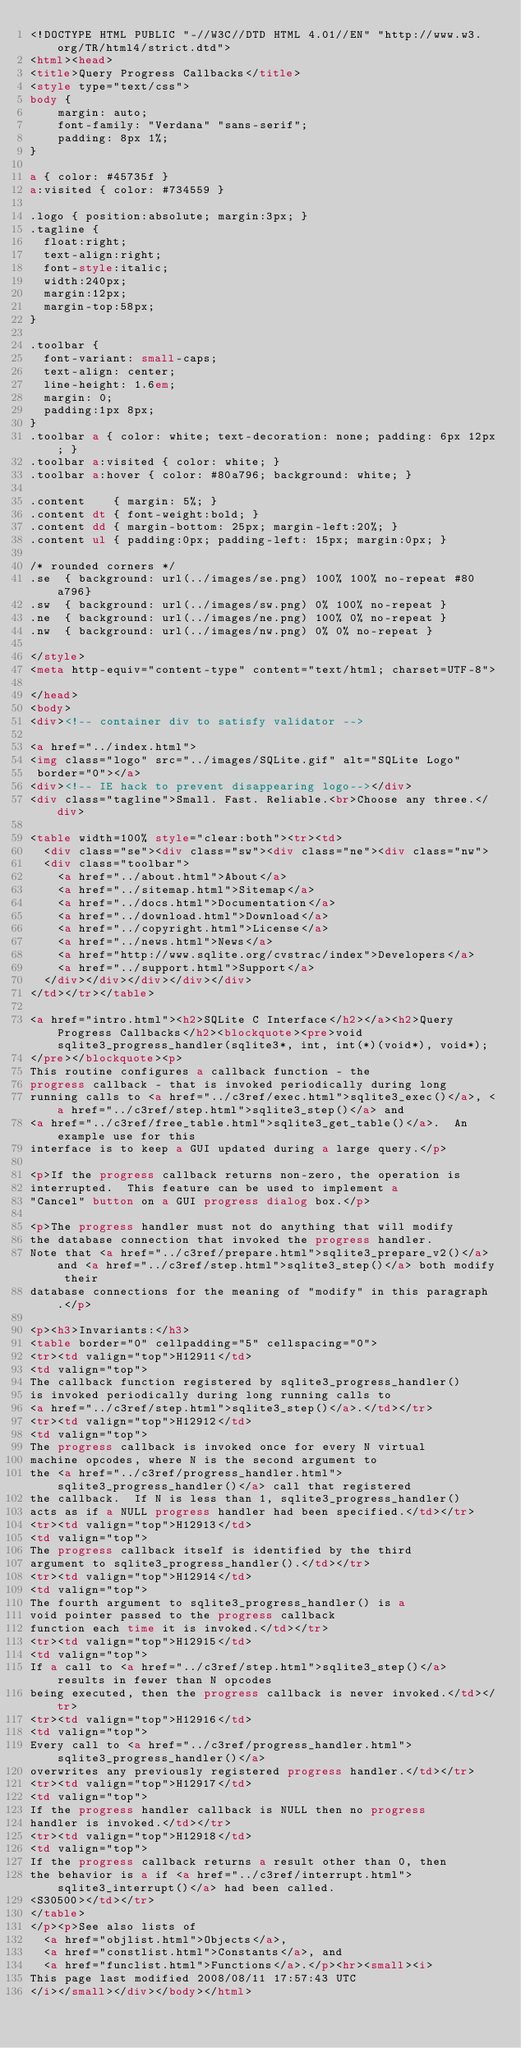<code> <loc_0><loc_0><loc_500><loc_500><_HTML_><!DOCTYPE HTML PUBLIC "-//W3C//DTD HTML 4.01//EN" "http://www.w3.org/TR/html4/strict.dtd">
<html><head>
<title>Query Progress Callbacks</title>
<style type="text/css">
body {
    margin: auto;
    font-family: "Verdana" "sans-serif";
    padding: 8px 1%;
}

a { color: #45735f }
a:visited { color: #734559 }

.logo { position:absolute; margin:3px; }
.tagline {
  float:right;
  text-align:right;
  font-style:italic;
  width:240px;
  margin:12px;
  margin-top:58px;
}

.toolbar {
  font-variant: small-caps;
  text-align: center;
  line-height: 1.6em;
  margin: 0;
  padding:1px 8px;
}
.toolbar a { color: white; text-decoration: none; padding: 6px 12px; }
.toolbar a:visited { color: white; }
.toolbar a:hover { color: #80a796; background: white; }

.content    { margin: 5%; }
.content dt { font-weight:bold; }
.content dd { margin-bottom: 25px; margin-left:20%; }
.content ul { padding:0px; padding-left: 15px; margin:0px; }

/* rounded corners */
.se  { background: url(../images/se.png) 100% 100% no-repeat #80a796}
.sw  { background: url(../images/sw.png) 0% 100% no-repeat }
.ne  { background: url(../images/ne.png) 100% 0% no-repeat }
.nw  { background: url(../images/nw.png) 0% 0% no-repeat }

</style>
<meta http-equiv="content-type" content="text/html; charset=UTF-8">
  
</head>
<body>
<div><!-- container div to satisfy validator -->

<a href="../index.html">
<img class="logo" src="../images/SQLite.gif" alt="SQLite Logo"
 border="0"></a>
<div><!-- IE hack to prevent disappearing logo--></div>
<div class="tagline">Small. Fast. Reliable.<br>Choose any three.</div>

<table width=100% style="clear:both"><tr><td>
  <div class="se"><div class="sw"><div class="ne"><div class="nw">
  <div class="toolbar">
    <a href="../about.html">About</a>
    <a href="../sitemap.html">Sitemap</a>
    <a href="../docs.html">Documentation</a>
    <a href="../download.html">Download</a>
    <a href="../copyright.html">License</a>
    <a href="../news.html">News</a>
    <a href="http://www.sqlite.org/cvstrac/index">Developers</a>
    <a href="../support.html">Support</a>
  </div></div></div></div></div>
</td></tr></table>
  
<a href="intro.html"><h2>SQLite C Interface</h2></a><h2>Query Progress Callbacks</h2><blockquote><pre>void sqlite3_progress_handler(sqlite3*, int, int(*)(void*), void*);
</pre></blockquote><p>
This routine configures a callback function - the
progress callback - that is invoked periodically during long
running calls to <a href="../c3ref/exec.html">sqlite3_exec()</a>, <a href="../c3ref/step.html">sqlite3_step()</a> and
<a href="../c3ref/free_table.html">sqlite3_get_table()</a>.  An example use for this
interface is to keep a GUI updated during a large query.</p>

<p>If the progress callback returns non-zero, the operation is
interrupted.  This feature can be used to implement a
"Cancel" button on a GUI progress dialog box.</p>

<p>The progress handler must not do anything that will modify
the database connection that invoked the progress handler.
Note that <a href="../c3ref/prepare.html">sqlite3_prepare_v2()</a> and <a href="../c3ref/step.html">sqlite3_step()</a> both modify their
database connections for the meaning of "modify" in this paragraph.</p>

<p><h3>Invariants:</h3>
<table border="0" cellpadding="5" cellspacing="0">
<tr><td valign="top">H12911</td> 
<td valign="top">
The callback function registered by sqlite3_progress_handler()
is invoked periodically during long running calls to
<a href="../c3ref/step.html">sqlite3_step()</a>.</td></tr>
<tr><td valign="top">H12912</td> 
<td valign="top">
The progress callback is invoked once for every N virtual
machine opcodes, where N is the second argument to
the <a href="../c3ref/progress_handler.html">sqlite3_progress_handler()</a> call that registered
the callback.  If N is less than 1, sqlite3_progress_handler()
acts as if a NULL progress handler had been specified.</td></tr>
<tr><td valign="top">H12913</td> 
<td valign="top">
The progress callback itself is identified by the third
argument to sqlite3_progress_handler().</td></tr>
<tr><td valign="top">H12914</td> 
<td valign="top">
The fourth argument to sqlite3_progress_handler() is a
void pointer passed to the progress callback
function each time it is invoked.</td></tr>
<tr><td valign="top">H12915</td> 
<td valign="top">
If a call to <a href="../c3ref/step.html">sqlite3_step()</a> results in fewer than N opcodes
being executed, then the progress callback is never invoked.</td></tr>
<tr><td valign="top">H12916</td> 
<td valign="top">
Every call to <a href="../c3ref/progress_handler.html">sqlite3_progress_handler()</a>
overwrites any previously registered progress handler.</td></tr>
<tr><td valign="top">H12917</td> 
<td valign="top">
If the progress handler callback is NULL then no progress
handler is invoked.</td></tr>
<tr><td valign="top">H12918</td> 
<td valign="top">
If the progress callback returns a result other than 0, then
the behavior is a if <a href="../c3ref/interrupt.html">sqlite3_interrupt()</a> had been called.
<S30500></td></tr>
</table>
</p><p>See also lists of
  <a href="objlist.html">Objects</a>,
  <a href="constlist.html">Constants</a>, and
  <a href="funclist.html">Functions</a>.</p><hr><small><i>
This page last modified 2008/08/11 17:57:43 UTC
</i></small></div></body></html>
</code> 